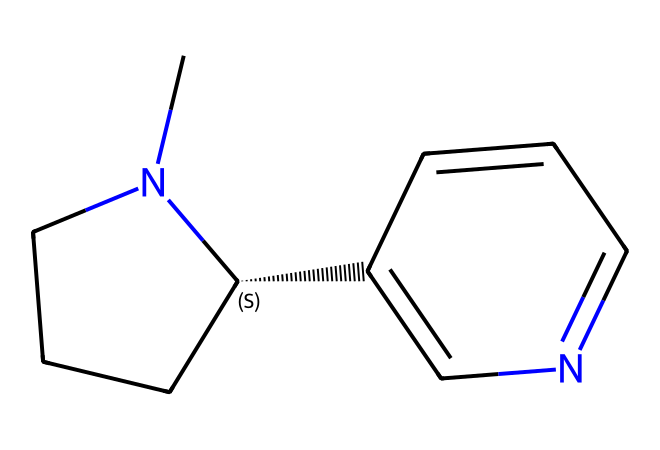How many carbon atoms are present in nicotine? By examining the SMILES representation, we count the 'C' symbols, which indicate carbon atoms. There are 10 carbon atoms in total.
Answer: 10 What is the functional group present in nicotine? Analyzing the structure, we identify the nitrogen atoms. The presence of a nitrogen atom indicates the presence of an amine functional group in this alkaloid.
Answer: amine How many rings are in the nicotine structure? The structure contains two distinct cyclic components, which can be identified from the numbers in the SMILES notation indicating ring closures. Thus, there are two rings.
Answer: 2 What type of molecule is nicotine classified as? Given that nicotine contains nitrogen and results from natural biosynthesis in plants, it is classified specifically as an alkaloid, derived from its nitrogen-containing structure.
Answer: alkaloid Is nicotine a polar or nonpolar molecule? By evaluating the heteroatoms present (particularly nitrogen), we can determine that nicotine exhibits polar characteristics due to nitrogen's electronegativity.
Answer: polar What is the total number of nitrogen atoms in nicotine? Looking at the SMILES representation, we count the 'N' symbols, which leads us to find that there are two nitrogen atoms present in the nicotine structure.
Answer: 2 